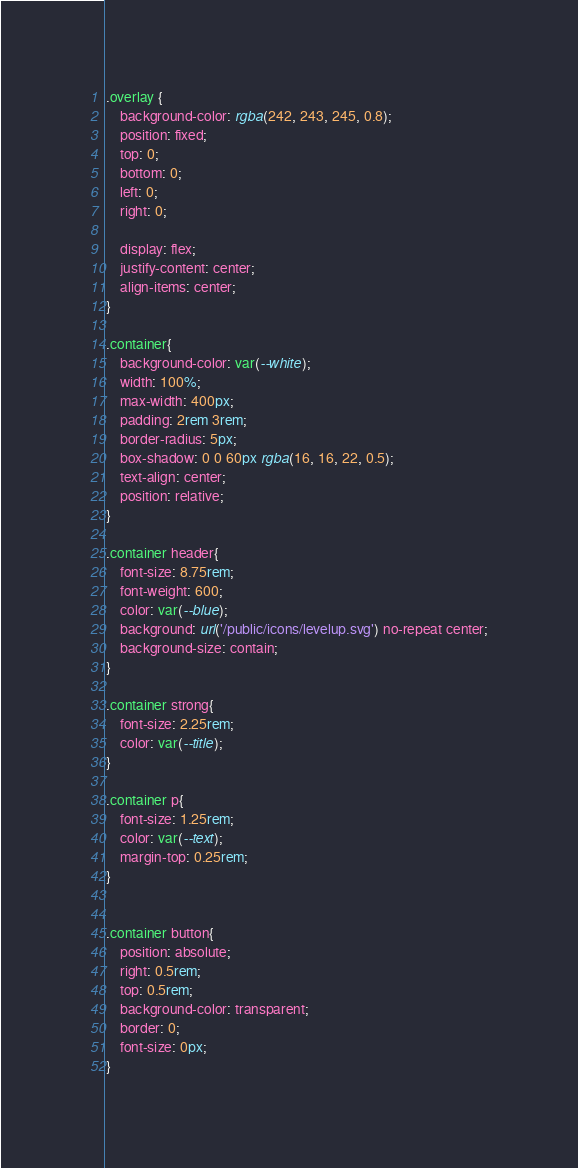<code> <loc_0><loc_0><loc_500><loc_500><_CSS_>.overlay {
    background-color: rgba(242, 243, 245, 0.8);
    position: fixed;
    top: 0;
    bottom: 0;
    left: 0;
    right: 0;

    display: flex;
    justify-content: center;
    align-items: center;
}

.container{
    background-color: var(--white);
    width: 100%;
    max-width: 400px;
    padding: 2rem 3rem;
    border-radius: 5px;
    box-shadow: 0 0 60px rgba(16, 16, 22, 0.5);
    text-align: center;
    position: relative;
}

.container header{
    font-size: 8.75rem;
    font-weight: 600;
    color: var(--blue);
    background: url('/public/icons/levelup.svg') no-repeat center;
    background-size: contain;
}

.container strong{
    font-size: 2.25rem;
    color: var(--title);
}

.container p{
    font-size: 1.25rem;
    color: var(--text);
    margin-top: 0.25rem;
}


.container button{
    position: absolute;
    right: 0.5rem;
    top: 0.5rem;
    background-color: transparent;
    border: 0;
    font-size: 0px;
}</code> 